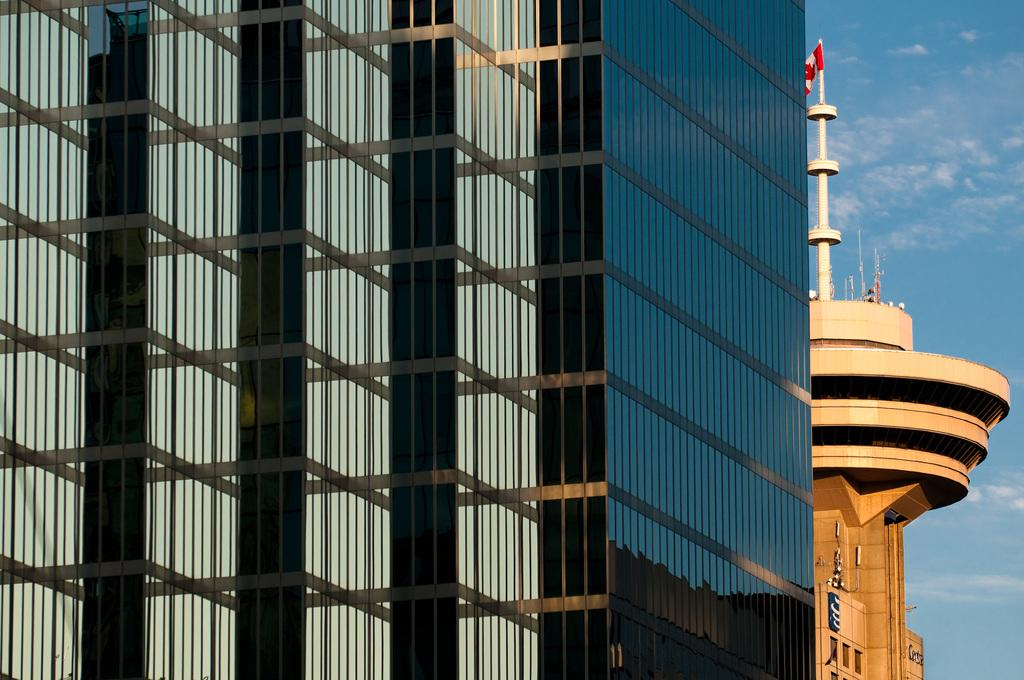What structures can be seen in the image? There are buildings in the image. Is there any specific feature on top of one of the buildings? Yes, a flag is present on top of a building. What can be seen in the background of the image? The sky is visible in the background of the image. What type of yarn is being used topped by the flag in the image? There is no yarn present in the image; the flag is on top of a building. What test is being conducted in the image? There is no test being conducted in the image; it features buildings and a flag on top of one of them. 